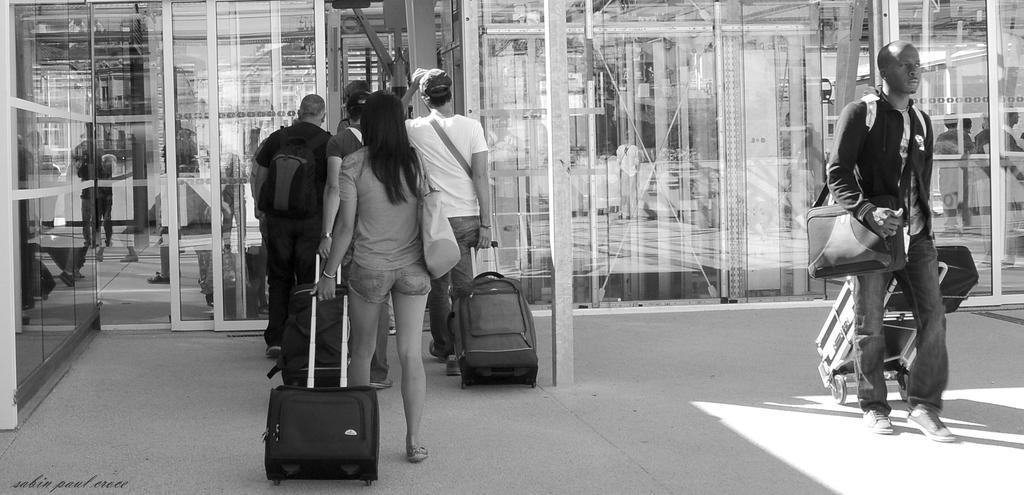How would you summarize this image in a sentence or two? There are few people walking in the road carrying luggage bags in their hands. In the background there are glass doors and few people behind the door. 